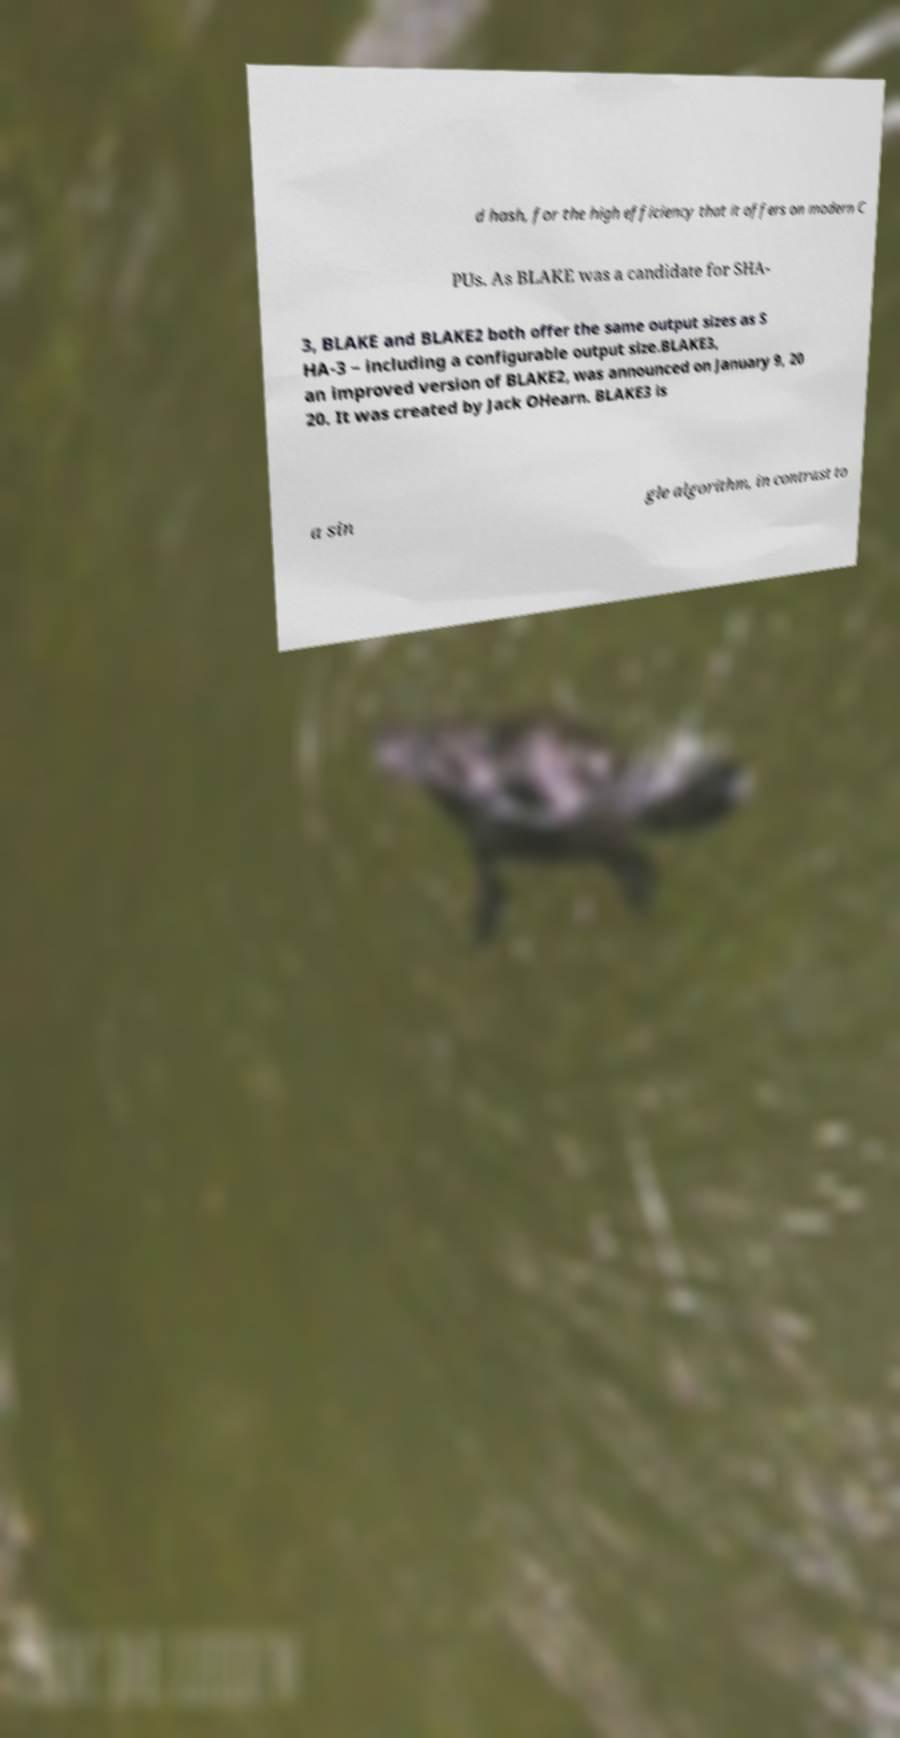For documentation purposes, I need the text within this image transcribed. Could you provide that? d hash, for the high efficiency that it offers on modern C PUs. As BLAKE was a candidate for SHA- 3, BLAKE and BLAKE2 both offer the same output sizes as S HA-3 – including a configurable output size.BLAKE3, an improved version of BLAKE2, was announced on January 9, 20 20. It was created by Jack OHearn. BLAKE3 is a sin gle algorithm, in contrast to 